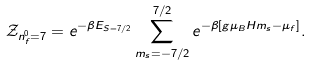Convert formula to latex. <formula><loc_0><loc_0><loc_500><loc_500>\mathcal { Z } _ { n _ { f } ^ { 0 } = 7 } = e ^ { - \beta E _ { S = 7 / 2 } } \sum _ { m _ { s } = - 7 / 2 } ^ { 7 / 2 } e ^ { - \beta [ g \mu _ { B } H m _ { s } - \mu _ { f } ] } .</formula> 